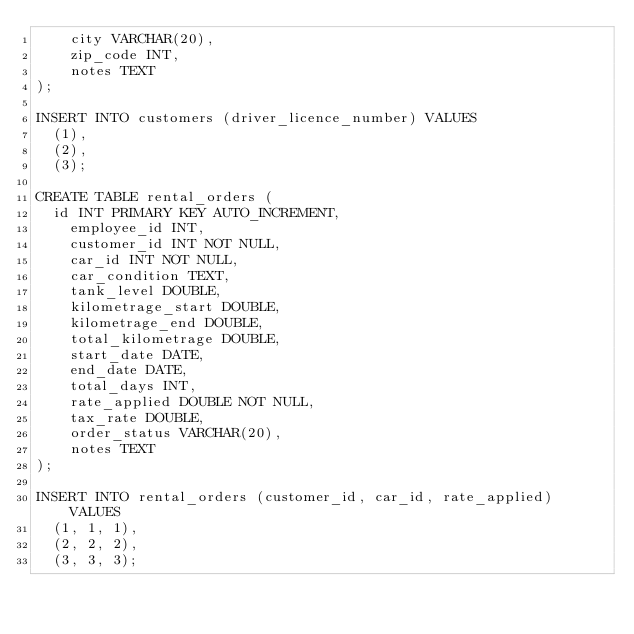<code> <loc_0><loc_0><loc_500><loc_500><_SQL_>    city VARCHAR(20),
    zip_code INT,
    notes TEXT
);

INSERT INTO customers (driver_licence_number) VALUES
	(1),
	(2),
	(3);
    
CREATE TABLE rental_orders (
	id INT PRIMARY KEY AUTO_INCREMENT,
    employee_id INT,
    customer_id INT NOT NULL,
    car_id INT NOT NULL,
    car_condition TEXT,
    tank_level DOUBLE,
    kilometrage_start DOUBLE,
    kilometrage_end DOUBLE,
    total_kilometrage DOUBLE,
    start_date DATE,
    end_date DATE,
    total_days INT,
    rate_applied DOUBLE NOT NULL,
    tax_rate DOUBLE,
    order_status VARCHAR(20),
    notes TEXT
);

INSERT INTO rental_orders (customer_id, car_id, rate_applied) VALUES
	(1, 1, 1),
	(2, 2, 2),
	(3, 3, 3);</code> 